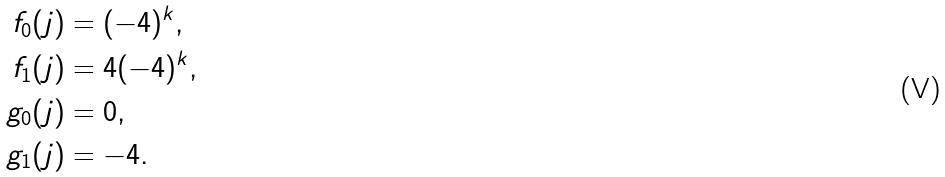Convert formula to latex. <formula><loc_0><loc_0><loc_500><loc_500>f _ { 0 } ( j ) & = ( - 4 ) ^ { k } , \\ f _ { 1 } ( j ) & = 4 ( - 4 ) ^ { k } , \\ g _ { 0 } ( j ) & = 0 , \\ g _ { 1 } ( j ) & = - 4 .</formula> 